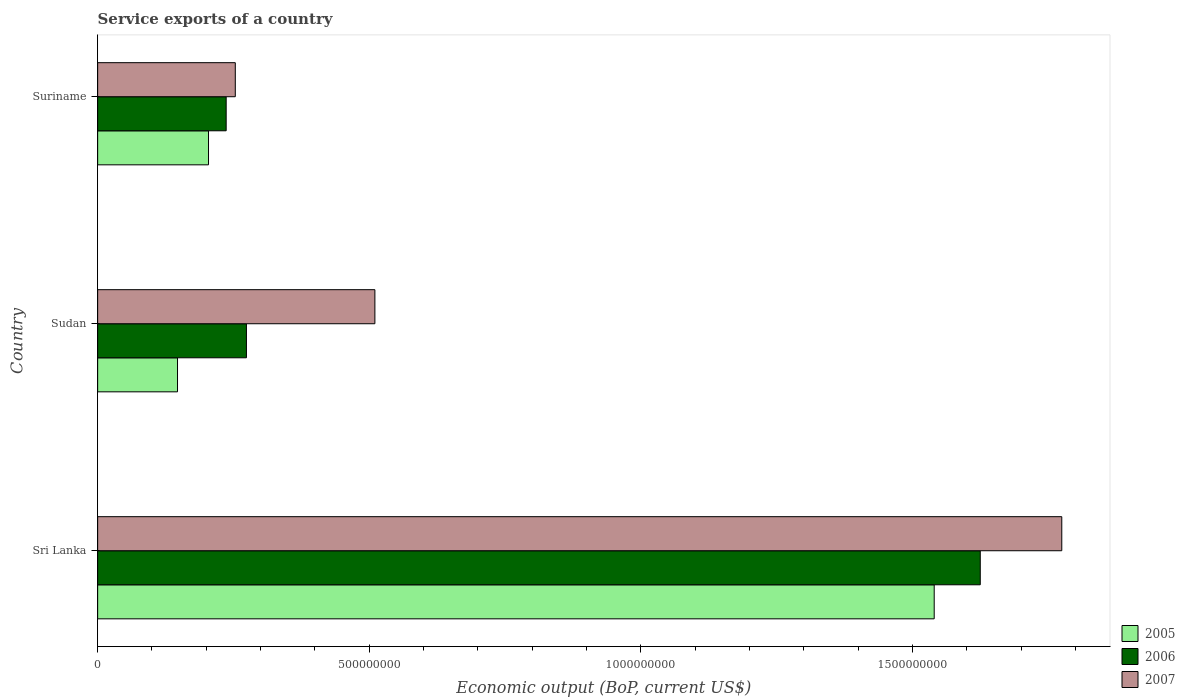How many groups of bars are there?
Your response must be concise. 3. Are the number of bars per tick equal to the number of legend labels?
Your answer should be very brief. Yes. What is the label of the 3rd group of bars from the top?
Give a very brief answer. Sri Lanka. In how many cases, is the number of bars for a given country not equal to the number of legend labels?
Provide a succinct answer. 0. What is the service exports in 2005 in Suriname?
Your answer should be compact. 2.04e+08. Across all countries, what is the maximum service exports in 2007?
Your response must be concise. 1.78e+09. Across all countries, what is the minimum service exports in 2007?
Provide a short and direct response. 2.53e+08. In which country was the service exports in 2007 maximum?
Make the answer very short. Sri Lanka. In which country was the service exports in 2007 minimum?
Provide a succinct answer. Suriname. What is the total service exports in 2007 in the graph?
Give a very brief answer. 2.54e+09. What is the difference between the service exports in 2006 in Sri Lanka and that in Sudan?
Offer a terse response. 1.35e+09. What is the difference between the service exports in 2005 in Sudan and the service exports in 2006 in Suriname?
Make the answer very short. -8.96e+07. What is the average service exports in 2007 per country?
Provide a short and direct response. 8.46e+08. What is the difference between the service exports in 2006 and service exports in 2007 in Sri Lanka?
Your answer should be very brief. -1.50e+08. In how many countries, is the service exports in 2007 greater than 1700000000 US$?
Your answer should be compact. 1. What is the ratio of the service exports in 2007 in Sudan to that in Suriname?
Ensure brevity in your answer.  2.01. Is the service exports in 2005 in Sri Lanka less than that in Suriname?
Provide a succinct answer. No. What is the difference between the highest and the second highest service exports in 2007?
Provide a succinct answer. 1.26e+09. What is the difference between the highest and the lowest service exports in 2006?
Keep it short and to the point. 1.39e+09. Is the sum of the service exports in 2006 in Sri Lanka and Sudan greater than the maximum service exports in 2005 across all countries?
Offer a very short reply. Yes. Is it the case that in every country, the sum of the service exports in 2005 and service exports in 2007 is greater than the service exports in 2006?
Offer a terse response. Yes. Are all the bars in the graph horizontal?
Offer a terse response. Yes. How many countries are there in the graph?
Your answer should be compact. 3. What is the difference between two consecutive major ticks on the X-axis?
Make the answer very short. 5.00e+08. Does the graph contain grids?
Offer a very short reply. No. What is the title of the graph?
Make the answer very short. Service exports of a country. What is the label or title of the X-axis?
Your answer should be compact. Economic output (BoP, current US$). What is the Economic output (BoP, current US$) of 2005 in Sri Lanka?
Provide a succinct answer. 1.54e+09. What is the Economic output (BoP, current US$) of 2006 in Sri Lanka?
Your response must be concise. 1.62e+09. What is the Economic output (BoP, current US$) of 2007 in Sri Lanka?
Make the answer very short. 1.78e+09. What is the Economic output (BoP, current US$) in 2005 in Sudan?
Keep it short and to the point. 1.47e+08. What is the Economic output (BoP, current US$) of 2006 in Sudan?
Provide a succinct answer. 2.74e+08. What is the Economic output (BoP, current US$) in 2007 in Sudan?
Offer a very short reply. 5.10e+08. What is the Economic output (BoP, current US$) in 2005 in Suriname?
Provide a succinct answer. 2.04e+08. What is the Economic output (BoP, current US$) in 2006 in Suriname?
Your response must be concise. 2.37e+08. What is the Economic output (BoP, current US$) in 2007 in Suriname?
Offer a terse response. 2.53e+08. Across all countries, what is the maximum Economic output (BoP, current US$) in 2005?
Keep it short and to the point. 1.54e+09. Across all countries, what is the maximum Economic output (BoP, current US$) of 2006?
Your answer should be compact. 1.62e+09. Across all countries, what is the maximum Economic output (BoP, current US$) in 2007?
Offer a terse response. 1.78e+09. Across all countries, what is the minimum Economic output (BoP, current US$) in 2005?
Give a very brief answer. 1.47e+08. Across all countries, what is the minimum Economic output (BoP, current US$) in 2006?
Provide a succinct answer. 2.37e+08. Across all countries, what is the minimum Economic output (BoP, current US$) in 2007?
Provide a succinct answer. 2.53e+08. What is the total Economic output (BoP, current US$) of 2005 in the graph?
Provide a succinct answer. 1.89e+09. What is the total Economic output (BoP, current US$) in 2006 in the graph?
Offer a very short reply. 2.14e+09. What is the total Economic output (BoP, current US$) of 2007 in the graph?
Keep it short and to the point. 2.54e+09. What is the difference between the Economic output (BoP, current US$) in 2005 in Sri Lanka and that in Sudan?
Provide a short and direct response. 1.39e+09. What is the difference between the Economic output (BoP, current US$) in 2006 in Sri Lanka and that in Sudan?
Your answer should be compact. 1.35e+09. What is the difference between the Economic output (BoP, current US$) of 2007 in Sri Lanka and that in Sudan?
Provide a succinct answer. 1.26e+09. What is the difference between the Economic output (BoP, current US$) in 2005 in Sri Lanka and that in Suriname?
Provide a succinct answer. 1.34e+09. What is the difference between the Economic output (BoP, current US$) of 2006 in Sri Lanka and that in Suriname?
Offer a very short reply. 1.39e+09. What is the difference between the Economic output (BoP, current US$) of 2007 in Sri Lanka and that in Suriname?
Your answer should be very brief. 1.52e+09. What is the difference between the Economic output (BoP, current US$) in 2005 in Sudan and that in Suriname?
Provide a short and direct response. -5.71e+07. What is the difference between the Economic output (BoP, current US$) of 2006 in Sudan and that in Suriname?
Keep it short and to the point. 3.73e+07. What is the difference between the Economic output (BoP, current US$) in 2007 in Sudan and that in Suriname?
Your answer should be very brief. 2.57e+08. What is the difference between the Economic output (BoP, current US$) in 2005 in Sri Lanka and the Economic output (BoP, current US$) in 2006 in Sudan?
Offer a terse response. 1.27e+09. What is the difference between the Economic output (BoP, current US$) of 2005 in Sri Lanka and the Economic output (BoP, current US$) of 2007 in Sudan?
Your response must be concise. 1.03e+09. What is the difference between the Economic output (BoP, current US$) of 2006 in Sri Lanka and the Economic output (BoP, current US$) of 2007 in Sudan?
Your answer should be compact. 1.11e+09. What is the difference between the Economic output (BoP, current US$) of 2005 in Sri Lanka and the Economic output (BoP, current US$) of 2006 in Suriname?
Keep it short and to the point. 1.30e+09. What is the difference between the Economic output (BoP, current US$) in 2005 in Sri Lanka and the Economic output (BoP, current US$) in 2007 in Suriname?
Ensure brevity in your answer.  1.29e+09. What is the difference between the Economic output (BoP, current US$) of 2006 in Sri Lanka and the Economic output (BoP, current US$) of 2007 in Suriname?
Your response must be concise. 1.37e+09. What is the difference between the Economic output (BoP, current US$) of 2005 in Sudan and the Economic output (BoP, current US$) of 2006 in Suriname?
Your response must be concise. -8.96e+07. What is the difference between the Economic output (BoP, current US$) in 2005 in Sudan and the Economic output (BoP, current US$) in 2007 in Suriname?
Your answer should be very brief. -1.06e+08. What is the difference between the Economic output (BoP, current US$) of 2006 in Sudan and the Economic output (BoP, current US$) of 2007 in Suriname?
Provide a succinct answer. 2.05e+07. What is the average Economic output (BoP, current US$) of 2005 per country?
Provide a succinct answer. 6.30e+08. What is the average Economic output (BoP, current US$) in 2006 per country?
Offer a very short reply. 7.12e+08. What is the average Economic output (BoP, current US$) in 2007 per country?
Your answer should be compact. 8.46e+08. What is the difference between the Economic output (BoP, current US$) in 2005 and Economic output (BoP, current US$) in 2006 in Sri Lanka?
Your response must be concise. -8.48e+07. What is the difference between the Economic output (BoP, current US$) of 2005 and Economic output (BoP, current US$) of 2007 in Sri Lanka?
Provide a short and direct response. -2.35e+08. What is the difference between the Economic output (BoP, current US$) in 2006 and Economic output (BoP, current US$) in 2007 in Sri Lanka?
Make the answer very short. -1.50e+08. What is the difference between the Economic output (BoP, current US$) in 2005 and Economic output (BoP, current US$) in 2006 in Sudan?
Provide a succinct answer. -1.27e+08. What is the difference between the Economic output (BoP, current US$) in 2005 and Economic output (BoP, current US$) in 2007 in Sudan?
Ensure brevity in your answer.  -3.63e+08. What is the difference between the Economic output (BoP, current US$) in 2006 and Economic output (BoP, current US$) in 2007 in Sudan?
Ensure brevity in your answer.  -2.36e+08. What is the difference between the Economic output (BoP, current US$) of 2005 and Economic output (BoP, current US$) of 2006 in Suriname?
Make the answer very short. -3.25e+07. What is the difference between the Economic output (BoP, current US$) in 2005 and Economic output (BoP, current US$) in 2007 in Suriname?
Provide a short and direct response. -4.93e+07. What is the difference between the Economic output (BoP, current US$) of 2006 and Economic output (BoP, current US$) of 2007 in Suriname?
Offer a very short reply. -1.68e+07. What is the ratio of the Economic output (BoP, current US$) in 2005 in Sri Lanka to that in Sudan?
Ensure brevity in your answer.  10.48. What is the ratio of the Economic output (BoP, current US$) of 2006 in Sri Lanka to that in Sudan?
Your response must be concise. 5.93. What is the ratio of the Economic output (BoP, current US$) in 2007 in Sri Lanka to that in Sudan?
Your answer should be very brief. 3.48. What is the ratio of the Economic output (BoP, current US$) in 2005 in Sri Lanka to that in Suriname?
Make the answer very short. 7.55. What is the ratio of the Economic output (BoP, current US$) in 2006 in Sri Lanka to that in Suriname?
Your response must be concise. 6.87. What is the ratio of the Economic output (BoP, current US$) in 2007 in Sri Lanka to that in Suriname?
Make the answer very short. 7. What is the ratio of the Economic output (BoP, current US$) of 2005 in Sudan to that in Suriname?
Ensure brevity in your answer.  0.72. What is the ratio of the Economic output (BoP, current US$) of 2006 in Sudan to that in Suriname?
Provide a succinct answer. 1.16. What is the ratio of the Economic output (BoP, current US$) in 2007 in Sudan to that in Suriname?
Give a very brief answer. 2.01. What is the difference between the highest and the second highest Economic output (BoP, current US$) in 2005?
Your answer should be compact. 1.34e+09. What is the difference between the highest and the second highest Economic output (BoP, current US$) of 2006?
Keep it short and to the point. 1.35e+09. What is the difference between the highest and the second highest Economic output (BoP, current US$) of 2007?
Keep it short and to the point. 1.26e+09. What is the difference between the highest and the lowest Economic output (BoP, current US$) in 2005?
Offer a very short reply. 1.39e+09. What is the difference between the highest and the lowest Economic output (BoP, current US$) of 2006?
Give a very brief answer. 1.39e+09. What is the difference between the highest and the lowest Economic output (BoP, current US$) of 2007?
Ensure brevity in your answer.  1.52e+09. 